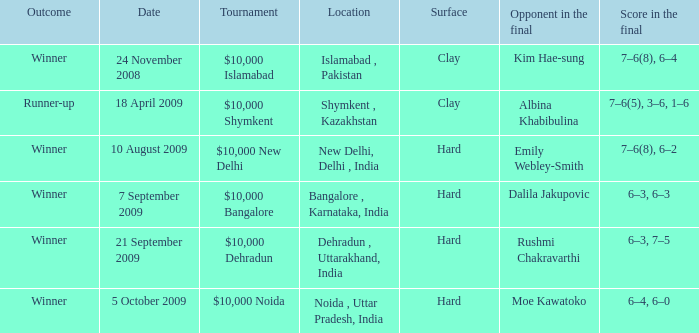Write the full table. {'header': ['Outcome', 'Date', 'Tournament', 'Location', 'Surface', 'Opponent in the final', 'Score in the final'], 'rows': [['Winner', '24 November 2008', '$10,000 Islamabad', 'Islamabad , Pakistan', 'Clay', 'Kim Hae-sung', '7–6(8), 6–4'], ['Runner-up', '18 April 2009', '$10,000 Shymkent', 'Shymkent , Kazakhstan', 'Clay', 'Albina Khabibulina', '7–6(5), 3–6, 1–6'], ['Winner', '10 August 2009', '$10,000 New Delhi', 'New Delhi, Delhi , India', 'Hard', 'Emily Webley-Smith', '7–6(8), 6–2'], ['Winner', '7 September 2009', '$10,000 Bangalore', 'Bangalore , Karnataka, India', 'Hard', 'Dalila Jakupovic', '6–3, 6–3'], ['Winner', '21 September 2009', '$10,000 Dehradun', 'Dehradun , Uttarakhand, India', 'Hard', 'Rushmi Chakravarthi', '6–3, 7–5'], ['Winner', '5 October 2009', '$10,000 Noida', 'Noida , Uttar Pradesh, India', 'Hard', 'Moe Kawatoko', '6–4, 6–0']]} What is the date of the match held in bangalore, karnataka, india location? 7 September 2009. 